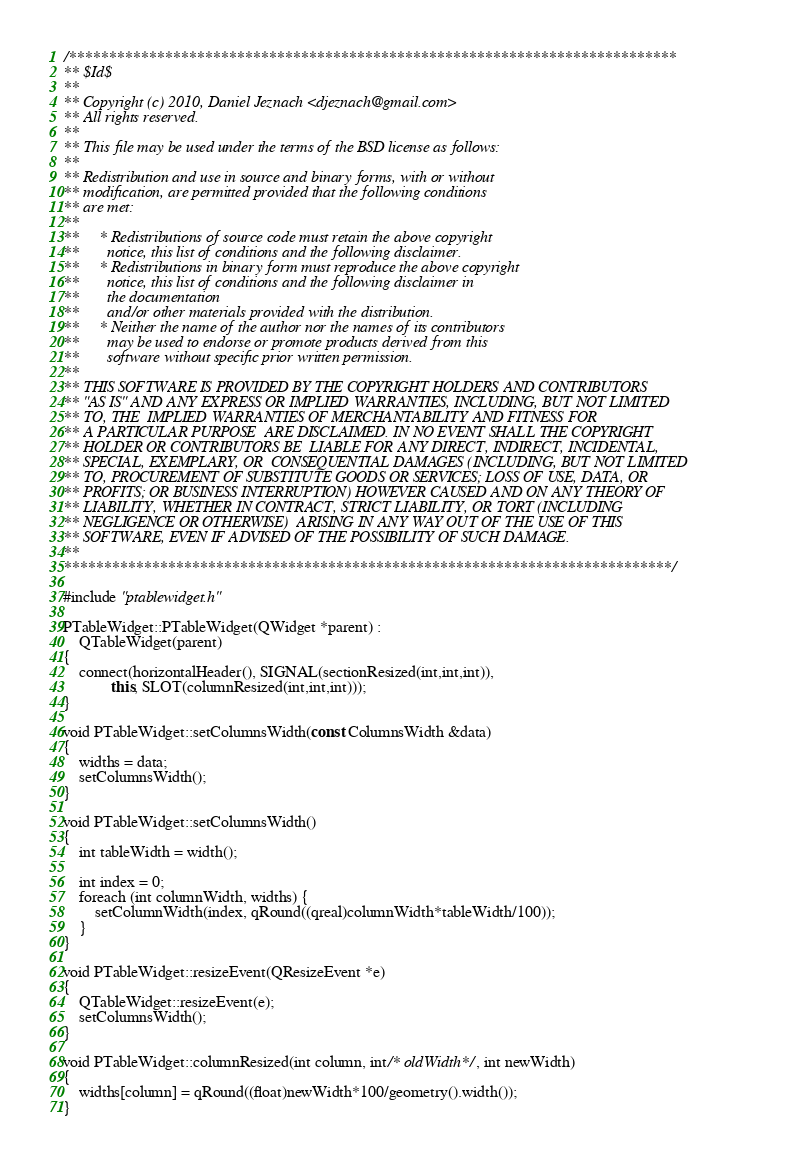Convert code to text. <code><loc_0><loc_0><loc_500><loc_500><_C++_>/****************************************************************************
** $Id$
**
** Copyright (c) 2010, Daniel Jeznach <djeznach@gmail.com>
** All rights reserved.
**
** This file may be used under the terms of the BSD license as follows:
**
** Redistribution and use in source and binary forms, with or without
** modification, are permitted provided that the following conditions
** are met:
**
**     * Redistributions of source code must retain the above copyright
**       notice, this list of conditions and the following disclaimer.
**     * Redistributions in binary form must reproduce the above copyright
**       notice, this list of conditions and the following disclaimer in
**       the documentation
**       and/or other materials provided with the distribution.
**     * Neither the name of the author nor the names of its contributors
**       may be used to endorse or promote products derived from this
**       software without specific prior written permission.
**
** THIS SOFTWARE IS PROVIDED BY THE COPYRIGHT HOLDERS AND CONTRIBUTORS
** "AS IS" AND ANY EXPRESS OR IMPLIED WARRANTIES, INCLUDING, BUT NOT LIMITED
** TO, THE  IMPLIED WARRANTIES OF MERCHANTABILITY AND FITNESS FOR
** A PARTICULAR PURPOSE  ARE DISCLAIMED. IN NO EVENT SHALL THE COPYRIGHT
** HOLDER OR CONTRIBUTORS BE  LIABLE FOR ANY DIRECT, INDIRECT, INCIDENTAL,
** SPECIAL, EXEMPLARY, OR  CONSEQUENTIAL DAMAGES (INCLUDING, BUT NOT LIMITED
** TO, PROCUREMENT OF SUBSTITUTE GOODS OR SERVICES; LOSS OF USE, DATA, OR
** PROFITS; OR BUSINESS INTERRUPTION) HOWEVER CAUSED AND ON ANY THEORY OF
** LIABILITY, WHETHER IN CONTRACT, STRICT LIABILITY, OR TORT (INCLUDING
** NEGLIGENCE OR OTHERWISE)  ARISING IN ANY WAY OUT OF THE USE OF THIS
** SOFTWARE, EVEN IF ADVISED OF THE POSSIBILITY OF SUCH DAMAGE.
**
****************************************************************************/

#include "ptablewidget.h"

PTableWidget::PTableWidget(QWidget *parent) :
    QTableWidget(parent)
{
    connect(horizontalHeader(), SIGNAL(sectionResized(int,int,int)),
            this, SLOT(columnResized(int,int,int)));
}

void PTableWidget::setColumnsWidth(const ColumnsWidth &data)
{
    widths = data;
    setColumnsWidth();
}

void PTableWidget::setColumnsWidth()
{
    int tableWidth = width();

    int index = 0;
    foreach (int columnWidth, widths) {
        setColumnWidth(index, qRound((qreal)columnWidth*tableWidth/100));
    }
}

void PTableWidget::resizeEvent(QResizeEvent *e)
{
    QTableWidget::resizeEvent(e);
    setColumnsWidth();
}

void PTableWidget::columnResized(int column, int/* oldWidth*/, int newWidth)
{
    widths[column] = qRound((float)newWidth*100/geometry().width());
}
</code> 